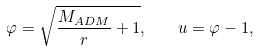<formula> <loc_0><loc_0><loc_500><loc_500>\varphi = \sqrt { \frac { M _ { A D M } } { r } + 1 } , \quad u = \varphi - 1 ,</formula> 